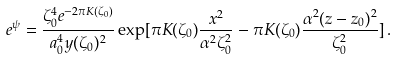<formula> <loc_0><loc_0><loc_500><loc_500>e ^ { \psi } = \frac { \zeta _ { 0 } ^ { 4 } e ^ { - 2 \pi K ( \zeta _ { 0 } ) } } { a _ { 0 } ^ { 4 } y ( \zeta _ { 0 } ) ^ { 2 } } \exp [ \pi K ( \zeta _ { 0 } ) \frac { x ^ { 2 } } { \alpha ^ { 2 } \zeta _ { 0 } ^ { 2 } } - \pi K ( \zeta _ { 0 } ) \frac { \alpha ^ { 2 } ( z - z _ { 0 } ) ^ { 2 } } { \zeta _ { 0 } ^ { 2 } } ] \, .</formula> 